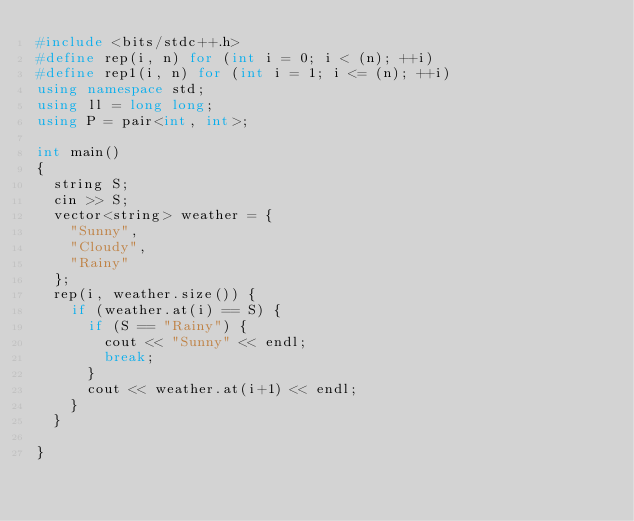Convert code to text. <code><loc_0><loc_0><loc_500><loc_500><_C++_>#include <bits/stdc++.h>
#define rep(i, n) for (int i = 0; i < (n); ++i)
#define rep1(i, n) for (int i = 1; i <= (n); ++i)
using namespace std;
using ll = long long;
using P = pair<int, int>;

int main()
{
  string S;
  cin >> S;
  vector<string> weather = {
    "Sunny",
    "Cloudy",
    "Rainy"
  };
  rep(i, weather.size()) {
    if (weather.at(i) == S) {
      if (S == "Rainy") {
        cout << "Sunny" << endl;
        break;
      }
      cout << weather.at(i+1) << endl;
    }
  }

}</code> 